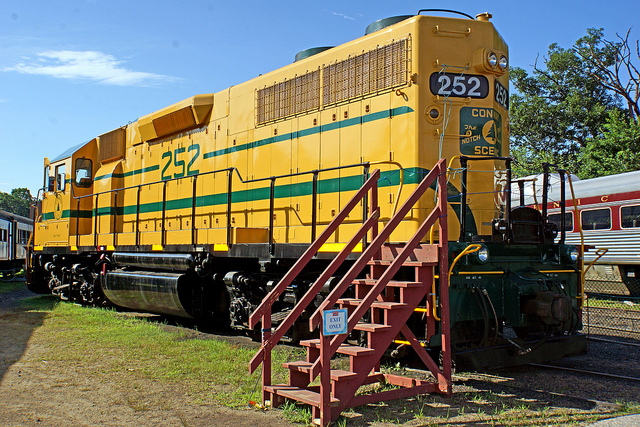Please transcribe the text in this image. 252 252 CON NOTCH SCE 252 